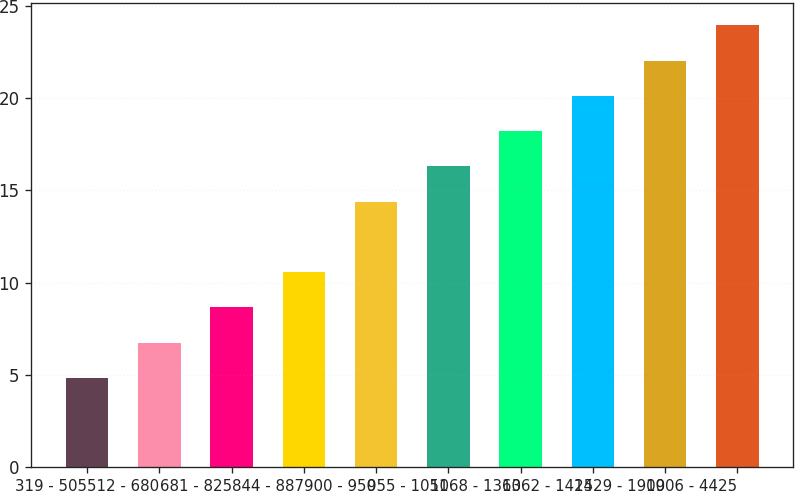Convert chart to OTSL. <chart><loc_0><loc_0><loc_500><loc_500><bar_chart><fcel>319 - 505<fcel>512 - 680<fcel>681 - 825<fcel>844 - 887<fcel>900 - 950<fcel>955 - 1051<fcel>1068 - 1360<fcel>1362 - 1425<fcel>1429 - 1900<fcel>1906 - 4425<nl><fcel>4.84<fcel>6.75<fcel>8.66<fcel>10.57<fcel>14.39<fcel>16.3<fcel>18.21<fcel>20.12<fcel>22.04<fcel>23.99<nl></chart> 